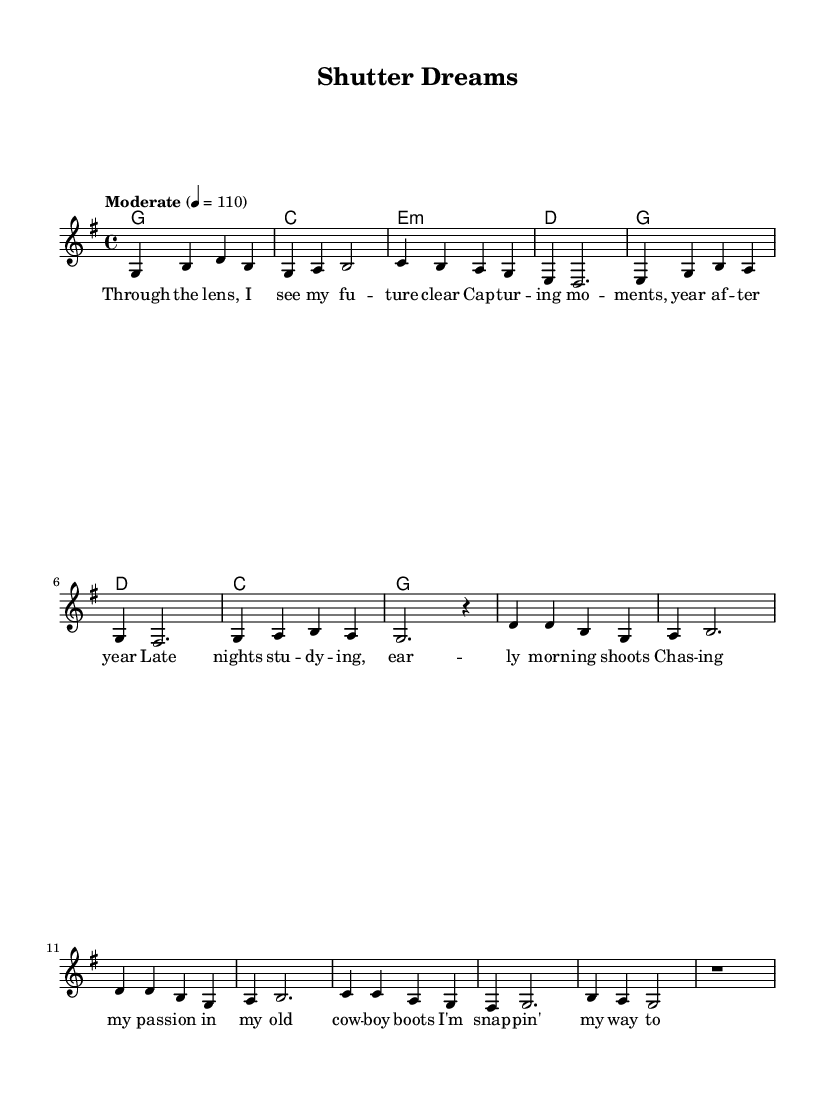What is the key signature of this music? The key signature is G major, indicated by one sharp.
Answer: G major What is the time signature of this music? The time signature is 4/4, which means there are four beats in each measure.
Answer: 4/4 What is the tempo marking for this music? The tempo marking is "Moderate" with a speed of 110 beats per minute.
Answer: Moderate How many measures are in the verse? The verse consists of 8 measures, as counted from the melody section.
Answer: 8 In which part of the song do we first encounter the lyrics about "chasing my passion"? The lyrics about "chasing my passion" appear in the verse, specifically in the fourth line.
Answer: Verse What chord follows the first measure of the chorus? The chord following the first measure of the chorus is D major, which transitions after the initial chord.
Answer: D How does the melody start in terms of note pitch? The melody starts on the note G, which is the first note played in the melody.
Answer: G 